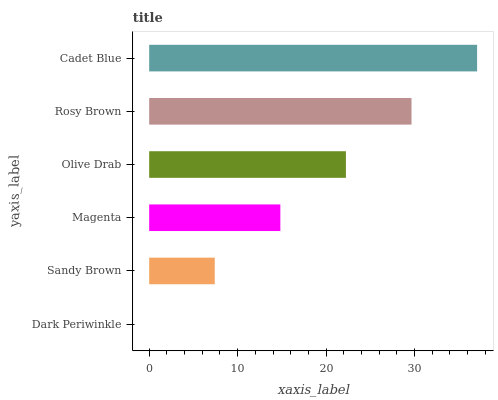Is Dark Periwinkle the minimum?
Answer yes or no. Yes. Is Cadet Blue the maximum?
Answer yes or no. Yes. Is Sandy Brown the minimum?
Answer yes or no. No. Is Sandy Brown the maximum?
Answer yes or no. No. Is Sandy Brown greater than Dark Periwinkle?
Answer yes or no. Yes. Is Dark Periwinkle less than Sandy Brown?
Answer yes or no. Yes. Is Dark Periwinkle greater than Sandy Brown?
Answer yes or no. No. Is Sandy Brown less than Dark Periwinkle?
Answer yes or no. No. Is Olive Drab the high median?
Answer yes or no. Yes. Is Magenta the low median?
Answer yes or no. Yes. Is Rosy Brown the high median?
Answer yes or no. No. Is Sandy Brown the low median?
Answer yes or no. No. 